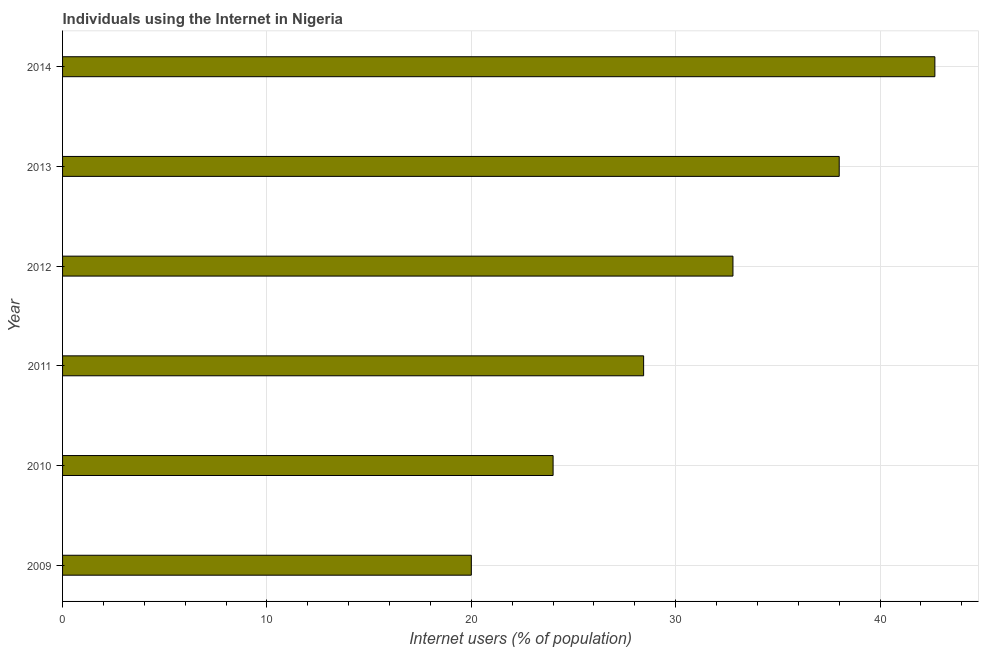What is the title of the graph?
Provide a succinct answer. Individuals using the Internet in Nigeria. What is the label or title of the X-axis?
Offer a terse response. Internet users (% of population). What is the label or title of the Y-axis?
Ensure brevity in your answer.  Year. What is the number of internet users in 2009?
Your answer should be very brief. 20. Across all years, what is the maximum number of internet users?
Give a very brief answer. 42.68. Across all years, what is the minimum number of internet users?
Keep it short and to the point. 20. What is the sum of the number of internet users?
Keep it short and to the point. 185.91. What is the difference between the number of internet users in 2011 and 2014?
Offer a terse response. -14.25. What is the average number of internet users per year?
Offer a very short reply. 30.98. What is the median number of internet users?
Provide a succinct answer. 30.61. Do a majority of the years between 2011 and 2010 (inclusive) have number of internet users greater than 14 %?
Provide a short and direct response. No. What is the ratio of the number of internet users in 2012 to that in 2013?
Offer a very short reply. 0.86. Is the number of internet users in 2011 less than that in 2013?
Ensure brevity in your answer.  Yes. What is the difference between the highest and the second highest number of internet users?
Your answer should be very brief. 4.68. Is the sum of the number of internet users in 2010 and 2013 greater than the maximum number of internet users across all years?
Make the answer very short. Yes. What is the difference between the highest and the lowest number of internet users?
Ensure brevity in your answer.  22.68. How many bars are there?
Keep it short and to the point. 6. What is the difference between two consecutive major ticks on the X-axis?
Provide a succinct answer. 10. Are the values on the major ticks of X-axis written in scientific E-notation?
Your response must be concise. No. What is the Internet users (% of population) in 2009?
Ensure brevity in your answer.  20. What is the Internet users (% of population) of 2011?
Provide a succinct answer. 28.43. What is the Internet users (% of population) in 2012?
Offer a very short reply. 32.8. What is the Internet users (% of population) in 2014?
Your response must be concise. 42.68. What is the difference between the Internet users (% of population) in 2009 and 2011?
Your answer should be very brief. -8.43. What is the difference between the Internet users (% of population) in 2009 and 2013?
Offer a very short reply. -18. What is the difference between the Internet users (% of population) in 2009 and 2014?
Ensure brevity in your answer.  -22.68. What is the difference between the Internet users (% of population) in 2010 and 2011?
Offer a very short reply. -4.43. What is the difference between the Internet users (% of population) in 2010 and 2012?
Your answer should be very brief. -8.8. What is the difference between the Internet users (% of population) in 2010 and 2014?
Offer a terse response. -18.68. What is the difference between the Internet users (% of population) in 2011 and 2012?
Your answer should be compact. -4.37. What is the difference between the Internet users (% of population) in 2011 and 2013?
Make the answer very short. -9.57. What is the difference between the Internet users (% of population) in 2011 and 2014?
Your answer should be very brief. -14.25. What is the difference between the Internet users (% of population) in 2012 and 2013?
Keep it short and to the point. -5.2. What is the difference between the Internet users (% of population) in 2012 and 2014?
Ensure brevity in your answer.  -9.88. What is the difference between the Internet users (% of population) in 2013 and 2014?
Keep it short and to the point. -4.68. What is the ratio of the Internet users (% of population) in 2009 to that in 2010?
Offer a very short reply. 0.83. What is the ratio of the Internet users (% of population) in 2009 to that in 2011?
Give a very brief answer. 0.7. What is the ratio of the Internet users (% of population) in 2009 to that in 2012?
Provide a succinct answer. 0.61. What is the ratio of the Internet users (% of population) in 2009 to that in 2013?
Provide a succinct answer. 0.53. What is the ratio of the Internet users (% of population) in 2009 to that in 2014?
Ensure brevity in your answer.  0.47. What is the ratio of the Internet users (% of population) in 2010 to that in 2011?
Provide a succinct answer. 0.84. What is the ratio of the Internet users (% of population) in 2010 to that in 2012?
Your answer should be compact. 0.73. What is the ratio of the Internet users (% of population) in 2010 to that in 2013?
Your answer should be very brief. 0.63. What is the ratio of the Internet users (% of population) in 2010 to that in 2014?
Give a very brief answer. 0.56. What is the ratio of the Internet users (% of population) in 2011 to that in 2012?
Offer a terse response. 0.87. What is the ratio of the Internet users (% of population) in 2011 to that in 2013?
Give a very brief answer. 0.75. What is the ratio of the Internet users (% of population) in 2011 to that in 2014?
Offer a very short reply. 0.67. What is the ratio of the Internet users (% of population) in 2012 to that in 2013?
Give a very brief answer. 0.86. What is the ratio of the Internet users (% of population) in 2012 to that in 2014?
Give a very brief answer. 0.77. What is the ratio of the Internet users (% of population) in 2013 to that in 2014?
Offer a terse response. 0.89. 